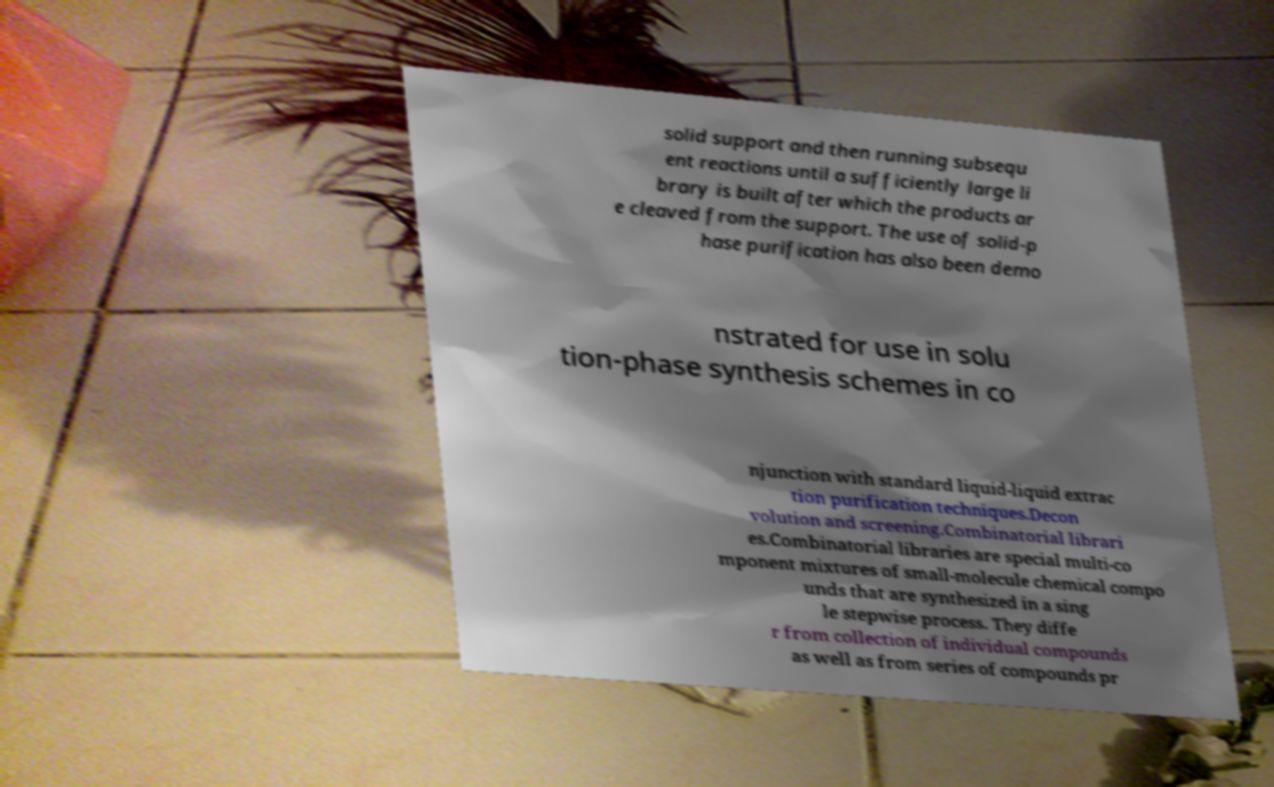There's text embedded in this image that I need extracted. Can you transcribe it verbatim? solid support and then running subsequ ent reactions until a sufficiently large li brary is built after which the products ar e cleaved from the support. The use of solid-p hase purification has also been demo nstrated for use in solu tion-phase synthesis schemes in co njunction with standard liquid-liquid extrac tion purification techniques.Decon volution and screening.Combinatorial librari es.Combinatorial libraries are special multi-co mponent mixtures of small-molecule chemical compo unds that are synthesized in a sing le stepwise process. They diffe r from collection of individual compounds as well as from series of compounds pr 